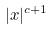Convert formula to latex. <formula><loc_0><loc_0><loc_500><loc_500>| x | ^ { c + 1 }</formula> 